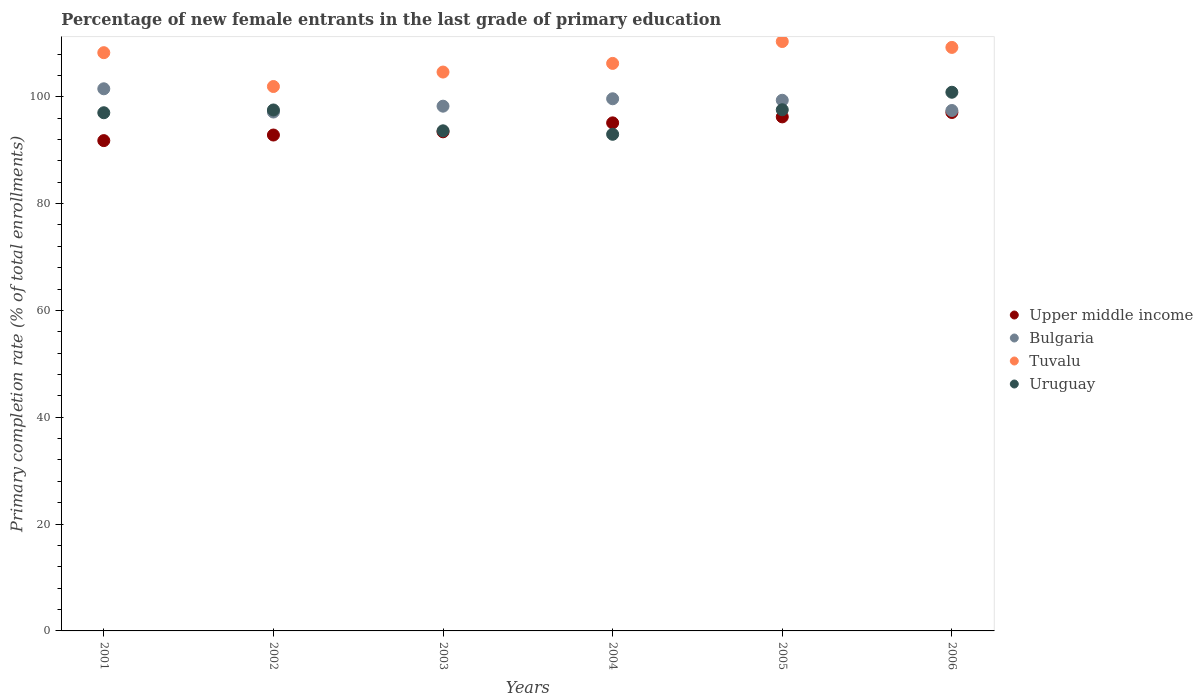How many different coloured dotlines are there?
Provide a short and direct response. 4. What is the percentage of new female entrants in Bulgaria in 2006?
Provide a succinct answer. 97.43. Across all years, what is the maximum percentage of new female entrants in Upper middle income?
Offer a terse response. 97.06. Across all years, what is the minimum percentage of new female entrants in Bulgaria?
Offer a terse response. 97.15. In which year was the percentage of new female entrants in Uruguay minimum?
Keep it short and to the point. 2004. What is the total percentage of new female entrants in Bulgaria in the graph?
Ensure brevity in your answer.  593.3. What is the difference between the percentage of new female entrants in Uruguay in 2004 and that in 2006?
Keep it short and to the point. -7.87. What is the difference between the percentage of new female entrants in Tuvalu in 2005 and the percentage of new female entrants in Upper middle income in 2001?
Provide a short and direct response. 18.55. What is the average percentage of new female entrants in Tuvalu per year?
Offer a very short reply. 106.77. In the year 2003, what is the difference between the percentage of new female entrants in Tuvalu and percentage of new female entrants in Uruguay?
Give a very brief answer. 11. What is the ratio of the percentage of new female entrants in Bulgaria in 2001 to that in 2006?
Provide a short and direct response. 1.04. Is the difference between the percentage of new female entrants in Tuvalu in 2002 and 2003 greater than the difference between the percentage of new female entrants in Uruguay in 2002 and 2003?
Make the answer very short. No. What is the difference between the highest and the second highest percentage of new female entrants in Uruguay?
Your answer should be compact. 3.28. What is the difference between the highest and the lowest percentage of new female entrants in Upper middle income?
Provide a short and direct response. 5.26. In how many years, is the percentage of new female entrants in Upper middle income greater than the average percentage of new female entrants in Upper middle income taken over all years?
Make the answer very short. 3. Is it the case that in every year, the sum of the percentage of new female entrants in Tuvalu and percentage of new female entrants in Upper middle income  is greater than the sum of percentage of new female entrants in Bulgaria and percentage of new female entrants in Uruguay?
Make the answer very short. Yes. Does the percentage of new female entrants in Uruguay monotonically increase over the years?
Give a very brief answer. No. Is the percentage of new female entrants in Bulgaria strictly greater than the percentage of new female entrants in Uruguay over the years?
Provide a short and direct response. No. Is the percentage of new female entrants in Tuvalu strictly less than the percentage of new female entrants in Upper middle income over the years?
Your answer should be compact. No. How many dotlines are there?
Keep it short and to the point. 4. How many years are there in the graph?
Give a very brief answer. 6. What is the difference between two consecutive major ticks on the Y-axis?
Your response must be concise. 20. Does the graph contain any zero values?
Your answer should be compact. No. How many legend labels are there?
Provide a short and direct response. 4. What is the title of the graph?
Your response must be concise. Percentage of new female entrants in the last grade of primary education. What is the label or title of the Y-axis?
Give a very brief answer. Primary completion rate (% of total enrollments). What is the Primary completion rate (% of total enrollments) in Upper middle income in 2001?
Your answer should be compact. 91.79. What is the Primary completion rate (% of total enrollments) of Bulgaria in 2001?
Offer a terse response. 101.5. What is the Primary completion rate (% of total enrollments) in Tuvalu in 2001?
Your answer should be very brief. 108.26. What is the Primary completion rate (% of total enrollments) of Uruguay in 2001?
Your response must be concise. 97.01. What is the Primary completion rate (% of total enrollments) of Upper middle income in 2002?
Provide a short and direct response. 92.84. What is the Primary completion rate (% of total enrollments) of Bulgaria in 2002?
Your answer should be very brief. 97.15. What is the Primary completion rate (% of total enrollments) of Tuvalu in 2002?
Your answer should be compact. 101.92. What is the Primary completion rate (% of total enrollments) in Uruguay in 2002?
Provide a succinct answer. 97.53. What is the Primary completion rate (% of total enrollments) in Upper middle income in 2003?
Your answer should be very brief. 93.44. What is the Primary completion rate (% of total enrollments) in Bulgaria in 2003?
Give a very brief answer. 98.24. What is the Primary completion rate (% of total enrollments) in Tuvalu in 2003?
Your answer should be very brief. 104.63. What is the Primary completion rate (% of total enrollments) in Uruguay in 2003?
Ensure brevity in your answer.  93.63. What is the Primary completion rate (% of total enrollments) in Upper middle income in 2004?
Provide a short and direct response. 95.12. What is the Primary completion rate (% of total enrollments) of Bulgaria in 2004?
Give a very brief answer. 99.63. What is the Primary completion rate (% of total enrollments) in Tuvalu in 2004?
Your response must be concise. 106.25. What is the Primary completion rate (% of total enrollments) in Uruguay in 2004?
Offer a very short reply. 92.98. What is the Primary completion rate (% of total enrollments) in Upper middle income in 2005?
Keep it short and to the point. 96.24. What is the Primary completion rate (% of total enrollments) in Bulgaria in 2005?
Give a very brief answer. 99.35. What is the Primary completion rate (% of total enrollments) of Tuvalu in 2005?
Offer a terse response. 110.34. What is the Primary completion rate (% of total enrollments) in Uruguay in 2005?
Your answer should be very brief. 97.57. What is the Primary completion rate (% of total enrollments) of Upper middle income in 2006?
Offer a very short reply. 97.06. What is the Primary completion rate (% of total enrollments) in Bulgaria in 2006?
Keep it short and to the point. 97.43. What is the Primary completion rate (% of total enrollments) in Tuvalu in 2006?
Provide a succinct answer. 109.24. What is the Primary completion rate (% of total enrollments) in Uruguay in 2006?
Keep it short and to the point. 100.85. Across all years, what is the maximum Primary completion rate (% of total enrollments) in Upper middle income?
Give a very brief answer. 97.06. Across all years, what is the maximum Primary completion rate (% of total enrollments) of Bulgaria?
Your response must be concise. 101.5. Across all years, what is the maximum Primary completion rate (% of total enrollments) in Tuvalu?
Make the answer very short. 110.34. Across all years, what is the maximum Primary completion rate (% of total enrollments) of Uruguay?
Make the answer very short. 100.85. Across all years, what is the minimum Primary completion rate (% of total enrollments) in Upper middle income?
Your answer should be compact. 91.79. Across all years, what is the minimum Primary completion rate (% of total enrollments) in Bulgaria?
Your answer should be compact. 97.15. Across all years, what is the minimum Primary completion rate (% of total enrollments) in Tuvalu?
Your answer should be compact. 101.92. Across all years, what is the minimum Primary completion rate (% of total enrollments) of Uruguay?
Offer a very short reply. 92.98. What is the total Primary completion rate (% of total enrollments) of Upper middle income in the graph?
Offer a very short reply. 566.49. What is the total Primary completion rate (% of total enrollments) in Bulgaria in the graph?
Keep it short and to the point. 593.3. What is the total Primary completion rate (% of total enrollments) in Tuvalu in the graph?
Provide a short and direct response. 640.65. What is the total Primary completion rate (% of total enrollments) of Uruguay in the graph?
Offer a terse response. 579.57. What is the difference between the Primary completion rate (% of total enrollments) of Upper middle income in 2001 and that in 2002?
Offer a terse response. -1.05. What is the difference between the Primary completion rate (% of total enrollments) in Bulgaria in 2001 and that in 2002?
Make the answer very short. 4.35. What is the difference between the Primary completion rate (% of total enrollments) of Tuvalu in 2001 and that in 2002?
Provide a succinct answer. 6.33. What is the difference between the Primary completion rate (% of total enrollments) in Uruguay in 2001 and that in 2002?
Your answer should be very brief. -0.52. What is the difference between the Primary completion rate (% of total enrollments) of Upper middle income in 2001 and that in 2003?
Your answer should be compact. -1.65. What is the difference between the Primary completion rate (% of total enrollments) in Bulgaria in 2001 and that in 2003?
Provide a succinct answer. 3.26. What is the difference between the Primary completion rate (% of total enrollments) of Tuvalu in 2001 and that in 2003?
Offer a terse response. 3.63. What is the difference between the Primary completion rate (% of total enrollments) in Uruguay in 2001 and that in 2003?
Your answer should be very brief. 3.38. What is the difference between the Primary completion rate (% of total enrollments) of Upper middle income in 2001 and that in 2004?
Ensure brevity in your answer.  -3.32. What is the difference between the Primary completion rate (% of total enrollments) of Bulgaria in 2001 and that in 2004?
Your answer should be compact. 1.87. What is the difference between the Primary completion rate (% of total enrollments) of Tuvalu in 2001 and that in 2004?
Your response must be concise. 2.01. What is the difference between the Primary completion rate (% of total enrollments) in Uruguay in 2001 and that in 2004?
Your answer should be compact. 4.03. What is the difference between the Primary completion rate (% of total enrollments) in Upper middle income in 2001 and that in 2005?
Offer a terse response. -4.44. What is the difference between the Primary completion rate (% of total enrollments) in Bulgaria in 2001 and that in 2005?
Provide a short and direct response. 2.15. What is the difference between the Primary completion rate (% of total enrollments) in Tuvalu in 2001 and that in 2005?
Your answer should be compact. -2.09. What is the difference between the Primary completion rate (% of total enrollments) of Uruguay in 2001 and that in 2005?
Offer a terse response. -0.56. What is the difference between the Primary completion rate (% of total enrollments) in Upper middle income in 2001 and that in 2006?
Ensure brevity in your answer.  -5.26. What is the difference between the Primary completion rate (% of total enrollments) in Bulgaria in 2001 and that in 2006?
Your answer should be very brief. 4.07. What is the difference between the Primary completion rate (% of total enrollments) of Tuvalu in 2001 and that in 2006?
Your answer should be very brief. -0.99. What is the difference between the Primary completion rate (% of total enrollments) of Uruguay in 2001 and that in 2006?
Your answer should be compact. -3.84. What is the difference between the Primary completion rate (% of total enrollments) of Upper middle income in 2002 and that in 2003?
Give a very brief answer. -0.6. What is the difference between the Primary completion rate (% of total enrollments) of Bulgaria in 2002 and that in 2003?
Offer a very short reply. -1.1. What is the difference between the Primary completion rate (% of total enrollments) of Tuvalu in 2002 and that in 2003?
Provide a short and direct response. -2.71. What is the difference between the Primary completion rate (% of total enrollments) of Uruguay in 2002 and that in 2003?
Your response must be concise. 3.9. What is the difference between the Primary completion rate (% of total enrollments) of Upper middle income in 2002 and that in 2004?
Provide a short and direct response. -2.28. What is the difference between the Primary completion rate (% of total enrollments) in Bulgaria in 2002 and that in 2004?
Provide a succinct answer. -2.48. What is the difference between the Primary completion rate (% of total enrollments) of Tuvalu in 2002 and that in 2004?
Ensure brevity in your answer.  -4.33. What is the difference between the Primary completion rate (% of total enrollments) of Uruguay in 2002 and that in 2004?
Make the answer very short. 4.55. What is the difference between the Primary completion rate (% of total enrollments) of Upper middle income in 2002 and that in 2005?
Keep it short and to the point. -3.4. What is the difference between the Primary completion rate (% of total enrollments) in Bulgaria in 2002 and that in 2005?
Provide a short and direct response. -2.2. What is the difference between the Primary completion rate (% of total enrollments) of Tuvalu in 2002 and that in 2005?
Ensure brevity in your answer.  -8.42. What is the difference between the Primary completion rate (% of total enrollments) in Uruguay in 2002 and that in 2005?
Keep it short and to the point. -0.04. What is the difference between the Primary completion rate (% of total enrollments) in Upper middle income in 2002 and that in 2006?
Make the answer very short. -4.22. What is the difference between the Primary completion rate (% of total enrollments) of Bulgaria in 2002 and that in 2006?
Keep it short and to the point. -0.29. What is the difference between the Primary completion rate (% of total enrollments) in Tuvalu in 2002 and that in 2006?
Your answer should be compact. -7.32. What is the difference between the Primary completion rate (% of total enrollments) in Uruguay in 2002 and that in 2006?
Your response must be concise. -3.32. What is the difference between the Primary completion rate (% of total enrollments) of Upper middle income in 2003 and that in 2004?
Your response must be concise. -1.68. What is the difference between the Primary completion rate (% of total enrollments) of Bulgaria in 2003 and that in 2004?
Make the answer very short. -1.39. What is the difference between the Primary completion rate (% of total enrollments) in Tuvalu in 2003 and that in 2004?
Provide a short and direct response. -1.62. What is the difference between the Primary completion rate (% of total enrollments) in Uruguay in 2003 and that in 2004?
Your response must be concise. 0.65. What is the difference between the Primary completion rate (% of total enrollments) of Upper middle income in 2003 and that in 2005?
Your answer should be compact. -2.8. What is the difference between the Primary completion rate (% of total enrollments) in Bulgaria in 2003 and that in 2005?
Your answer should be very brief. -1.1. What is the difference between the Primary completion rate (% of total enrollments) of Tuvalu in 2003 and that in 2005?
Make the answer very short. -5.72. What is the difference between the Primary completion rate (% of total enrollments) in Uruguay in 2003 and that in 2005?
Your answer should be compact. -3.94. What is the difference between the Primary completion rate (% of total enrollments) of Upper middle income in 2003 and that in 2006?
Make the answer very short. -3.62. What is the difference between the Primary completion rate (% of total enrollments) of Bulgaria in 2003 and that in 2006?
Your answer should be compact. 0.81. What is the difference between the Primary completion rate (% of total enrollments) in Tuvalu in 2003 and that in 2006?
Offer a terse response. -4.61. What is the difference between the Primary completion rate (% of total enrollments) in Uruguay in 2003 and that in 2006?
Make the answer very short. -7.22. What is the difference between the Primary completion rate (% of total enrollments) in Upper middle income in 2004 and that in 2005?
Keep it short and to the point. -1.12. What is the difference between the Primary completion rate (% of total enrollments) of Bulgaria in 2004 and that in 2005?
Keep it short and to the point. 0.28. What is the difference between the Primary completion rate (% of total enrollments) in Tuvalu in 2004 and that in 2005?
Provide a succinct answer. -4.09. What is the difference between the Primary completion rate (% of total enrollments) of Uruguay in 2004 and that in 2005?
Your response must be concise. -4.59. What is the difference between the Primary completion rate (% of total enrollments) in Upper middle income in 2004 and that in 2006?
Give a very brief answer. -1.94. What is the difference between the Primary completion rate (% of total enrollments) of Bulgaria in 2004 and that in 2006?
Make the answer very short. 2.2. What is the difference between the Primary completion rate (% of total enrollments) in Tuvalu in 2004 and that in 2006?
Keep it short and to the point. -2.99. What is the difference between the Primary completion rate (% of total enrollments) in Uruguay in 2004 and that in 2006?
Provide a succinct answer. -7.87. What is the difference between the Primary completion rate (% of total enrollments) of Upper middle income in 2005 and that in 2006?
Provide a succinct answer. -0.82. What is the difference between the Primary completion rate (% of total enrollments) of Bulgaria in 2005 and that in 2006?
Offer a very short reply. 1.91. What is the difference between the Primary completion rate (% of total enrollments) of Tuvalu in 2005 and that in 2006?
Offer a very short reply. 1.1. What is the difference between the Primary completion rate (% of total enrollments) in Uruguay in 2005 and that in 2006?
Your response must be concise. -3.28. What is the difference between the Primary completion rate (% of total enrollments) in Upper middle income in 2001 and the Primary completion rate (% of total enrollments) in Bulgaria in 2002?
Provide a succinct answer. -5.35. What is the difference between the Primary completion rate (% of total enrollments) in Upper middle income in 2001 and the Primary completion rate (% of total enrollments) in Tuvalu in 2002?
Offer a terse response. -10.13. What is the difference between the Primary completion rate (% of total enrollments) in Upper middle income in 2001 and the Primary completion rate (% of total enrollments) in Uruguay in 2002?
Make the answer very short. -5.74. What is the difference between the Primary completion rate (% of total enrollments) in Bulgaria in 2001 and the Primary completion rate (% of total enrollments) in Tuvalu in 2002?
Your answer should be compact. -0.43. What is the difference between the Primary completion rate (% of total enrollments) in Bulgaria in 2001 and the Primary completion rate (% of total enrollments) in Uruguay in 2002?
Your response must be concise. 3.97. What is the difference between the Primary completion rate (% of total enrollments) in Tuvalu in 2001 and the Primary completion rate (% of total enrollments) in Uruguay in 2002?
Make the answer very short. 10.73. What is the difference between the Primary completion rate (% of total enrollments) of Upper middle income in 2001 and the Primary completion rate (% of total enrollments) of Bulgaria in 2003?
Offer a very short reply. -6.45. What is the difference between the Primary completion rate (% of total enrollments) of Upper middle income in 2001 and the Primary completion rate (% of total enrollments) of Tuvalu in 2003?
Your answer should be compact. -12.84. What is the difference between the Primary completion rate (% of total enrollments) in Upper middle income in 2001 and the Primary completion rate (% of total enrollments) in Uruguay in 2003?
Ensure brevity in your answer.  -1.83. What is the difference between the Primary completion rate (% of total enrollments) of Bulgaria in 2001 and the Primary completion rate (% of total enrollments) of Tuvalu in 2003?
Your answer should be very brief. -3.13. What is the difference between the Primary completion rate (% of total enrollments) in Bulgaria in 2001 and the Primary completion rate (% of total enrollments) in Uruguay in 2003?
Provide a short and direct response. 7.87. What is the difference between the Primary completion rate (% of total enrollments) in Tuvalu in 2001 and the Primary completion rate (% of total enrollments) in Uruguay in 2003?
Your response must be concise. 14.63. What is the difference between the Primary completion rate (% of total enrollments) of Upper middle income in 2001 and the Primary completion rate (% of total enrollments) of Bulgaria in 2004?
Offer a terse response. -7.83. What is the difference between the Primary completion rate (% of total enrollments) in Upper middle income in 2001 and the Primary completion rate (% of total enrollments) in Tuvalu in 2004?
Ensure brevity in your answer.  -14.46. What is the difference between the Primary completion rate (% of total enrollments) of Upper middle income in 2001 and the Primary completion rate (% of total enrollments) of Uruguay in 2004?
Your answer should be compact. -1.18. What is the difference between the Primary completion rate (% of total enrollments) of Bulgaria in 2001 and the Primary completion rate (% of total enrollments) of Tuvalu in 2004?
Make the answer very short. -4.75. What is the difference between the Primary completion rate (% of total enrollments) in Bulgaria in 2001 and the Primary completion rate (% of total enrollments) in Uruguay in 2004?
Your response must be concise. 8.52. What is the difference between the Primary completion rate (% of total enrollments) in Tuvalu in 2001 and the Primary completion rate (% of total enrollments) in Uruguay in 2004?
Ensure brevity in your answer.  15.28. What is the difference between the Primary completion rate (% of total enrollments) in Upper middle income in 2001 and the Primary completion rate (% of total enrollments) in Bulgaria in 2005?
Ensure brevity in your answer.  -7.55. What is the difference between the Primary completion rate (% of total enrollments) in Upper middle income in 2001 and the Primary completion rate (% of total enrollments) in Tuvalu in 2005?
Keep it short and to the point. -18.55. What is the difference between the Primary completion rate (% of total enrollments) in Upper middle income in 2001 and the Primary completion rate (% of total enrollments) in Uruguay in 2005?
Provide a short and direct response. -5.78. What is the difference between the Primary completion rate (% of total enrollments) of Bulgaria in 2001 and the Primary completion rate (% of total enrollments) of Tuvalu in 2005?
Offer a very short reply. -8.85. What is the difference between the Primary completion rate (% of total enrollments) in Bulgaria in 2001 and the Primary completion rate (% of total enrollments) in Uruguay in 2005?
Give a very brief answer. 3.93. What is the difference between the Primary completion rate (% of total enrollments) of Tuvalu in 2001 and the Primary completion rate (% of total enrollments) of Uruguay in 2005?
Offer a terse response. 10.68. What is the difference between the Primary completion rate (% of total enrollments) in Upper middle income in 2001 and the Primary completion rate (% of total enrollments) in Bulgaria in 2006?
Your answer should be compact. -5.64. What is the difference between the Primary completion rate (% of total enrollments) of Upper middle income in 2001 and the Primary completion rate (% of total enrollments) of Tuvalu in 2006?
Your response must be concise. -17.45. What is the difference between the Primary completion rate (% of total enrollments) of Upper middle income in 2001 and the Primary completion rate (% of total enrollments) of Uruguay in 2006?
Offer a terse response. -9.05. What is the difference between the Primary completion rate (% of total enrollments) of Bulgaria in 2001 and the Primary completion rate (% of total enrollments) of Tuvalu in 2006?
Ensure brevity in your answer.  -7.75. What is the difference between the Primary completion rate (% of total enrollments) in Bulgaria in 2001 and the Primary completion rate (% of total enrollments) in Uruguay in 2006?
Make the answer very short. 0.65. What is the difference between the Primary completion rate (% of total enrollments) in Tuvalu in 2001 and the Primary completion rate (% of total enrollments) in Uruguay in 2006?
Ensure brevity in your answer.  7.41. What is the difference between the Primary completion rate (% of total enrollments) of Upper middle income in 2002 and the Primary completion rate (% of total enrollments) of Bulgaria in 2003?
Keep it short and to the point. -5.4. What is the difference between the Primary completion rate (% of total enrollments) in Upper middle income in 2002 and the Primary completion rate (% of total enrollments) in Tuvalu in 2003?
Make the answer very short. -11.79. What is the difference between the Primary completion rate (% of total enrollments) of Upper middle income in 2002 and the Primary completion rate (% of total enrollments) of Uruguay in 2003?
Your answer should be compact. -0.79. What is the difference between the Primary completion rate (% of total enrollments) of Bulgaria in 2002 and the Primary completion rate (% of total enrollments) of Tuvalu in 2003?
Make the answer very short. -7.48. What is the difference between the Primary completion rate (% of total enrollments) of Bulgaria in 2002 and the Primary completion rate (% of total enrollments) of Uruguay in 2003?
Give a very brief answer. 3.52. What is the difference between the Primary completion rate (% of total enrollments) in Tuvalu in 2002 and the Primary completion rate (% of total enrollments) in Uruguay in 2003?
Make the answer very short. 8.29. What is the difference between the Primary completion rate (% of total enrollments) in Upper middle income in 2002 and the Primary completion rate (% of total enrollments) in Bulgaria in 2004?
Offer a very short reply. -6.79. What is the difference between the Primary completion rate (% of total enrollments) of Upper middle income in 2002 and the Primary completion rate (% of total enrollments) of Tuvalu in 2004?
Keep it short and to the point. -13.41. What is the difference between the Primary completion rate (% of total enrollments) of Upper middle income in 2002 and the Primary completion rate (% of total enrollments) of Uruguay in 2004?
Your answer should be compact. -0.14. What is the difference between the Primary completion rate (% of total enrollments) in Bulgaria in 2002 and the Primary completion rate (% of total enrollments) in Tuvalu in 2004?
Offer a terse response. -9.1. What is the difference between the Primary completion rate (% of total enrollments) in Bulgaria in 2002 and the Primary completion rate (% of total enrollments) in Uruguay in 2004?
Your answer should be compact. 4.17. What is the difference between the Primary completion rate (% of total enrollments) of Tuvalu in 2002 and the Primary completion rate (% of total enrollments) of Uruguay in 2004?
Provide a short and direct response. 8.94. What is the difference between the Primary completion rate (% of total enrollments) of Upper middle income in 2002 and the Primary completion rate (% of total enrollments) of Bulgaria in 2005?
Ensure brevity in your answer.  -6.51. What is the difference between the Primary completion rate (% of total enrollments) of Upper middle income in 2002 and the Primary completion rate (% of total enrollments) of Tuvalu in 2005?
Your answer should be compact. -17.5. What is the difference between the Primary completion rate (% of total enrollments) of Upper middle income in 2002 and the Primary completion rate (% of total enrollments) of Uruguay in 2005?
Offer a very short reply. -4.73. What is the difference between the Primary completion rate (% of total enrollments) of Bulgaria in 2002 and the Primary completion rate (% of total enrollments) of Tuvalu in 2005?
Offer a very short reply. -13.2. What is the difference between the Primary completion rate (% of total enrollments) of Bulgaria in 2002 and the Primary completion rate (% of total enrollments) of Uruguay in 2005?
Keep it short and to the point. -0.43. What is the difference between the Primary completion rate (% of total enrollments) of Tuvalu in 2002 and the Primary completion rate (% of total enrollments) of Uruguay in 2005?
Offer a terse response. 4.35. What is the difference between the Primary completion rate (% of total enrollments) of Upper middle income in 2002 and the Primary completion rate (% of total enrollments) of Bulgaria in 2006?
Keep it short and to the point. -4.59. What is the difference between the Primary completion rate (% of total enrollments) of Upper middle income in 2002 and the Primary completion rate (% of total enrollments) of Tuvalu in 2006?
Offer a very short reply. -16.4. What is the difference between the Primary completion rate (% of total enrollments) in Upper middle income in 2002 and the Primary completion rate (% of total enrollments) in Uruguay in 2006?
Your response must be concise. -8.01. What is the difference between the Primary completion rate (% of total enrollments) of Bulgaria in 2002 and the Primary completion rate (% of total enrollments) of Tuvalu in 2006?
Provide a short and direct response. -12.1. What is the difference between the Primary completion rate (% of total enrollments) in Bulgaria in 2002 and the Primary completion rate (% of total enrollments) in Uruguay in 2006?
Keep it short and to the point. -3.7. What is the difference between the Primary completion rate (% of total enrollments) in Tuvalu in 2002 and the Primary completion rate (% of total enrollments) in Uruguay in 2006?
Make the answer very short. 1.07. What is the difference between the Primary completion rate (% of total enrollments) of Upper middle income in 2003 and the Primary completion rate (% of total enrollments) of Bulgaria in 2004?
Ensure brevity in your answer.  -6.19. What is the difference between the Primary completion rate (% of total enrollments) in Upper middle income in 2003 and the Primary completion rate (% of total enrollments) in Tuvalu in 2004?
Give a very brief answer. -12.81. What is the difference between the Primary completion rate (% of total enrollments) in Upper middle income in 2003 and the Primary completion rate (% of total enrollments) in Uruguay in 2004?
Offer a terse response. 0.46. What is the difference between the Primary completion rate (% of total enrollments) of Bulgaria in 2003 and the Primary completion rate (% of total enrollments) of Tuvalu in 2004?
Your answer should be very brief. -8.01. What is the difference between the Primary completion rate (% of total enrollments) of Bulgaria in 2003 and the Primary completion rate (% of total enrollments) of Uruguay in 2004?
Offer a terse response. 5.26. What is the difference between the Primary completion rate (% of total enrollments) of Tuvalu in 2003 and the Primary completion rate (% of total enrollments) of Uruguay in 2004?
Offer a terse response. 11.65. What is the difference between the Primary completion rate (% of total enrollments) in Upper middle income in 2003 and the Primary completion rate (% of total enrollments) in Bulgaria in 2005?
Your response must be concise. -5.91. What is the difference between the Primary completion rate (% of total enrollments) of Upper middle income in 2003 and the Primary completion rate (% of total enrollments) of Tuvalu in 2005?
Make the answer very short. -16.9. What is the difference between the Primary completion rate (% of total enrollments) of Upper middle income in 2003 and the Primary completion rate (% of total enrollments) of Uruguay in 2005?
Provide a short and direct response. -4.13. What is the difference between the Primary completion rate (% of total enrollments) in Bulgaria in 2003 and the Primary completion rate (% of total enrollments) in Tuvalu in 2005?
Ensure brevity in your answer.  -12.1. What is the difference between the Primary completion rate (% of total enrollments) in Bulgaria in 2003 and the Primary completion rate (% of total enrollments) in Uruguay in 2005?
Your answer should be very brief. 0.67. What is the difference between the Primary completion rate (% of total enrollments) in Tuvalu in 2003 and the Primary completion rate (% of total enrollments) in Uruguay in 2005?
Provide a succinct answer. 7.06. What is the difference between the Primary completion rate (% of total enrollments) in Upper middle income in 2003 and the Primary completion rate (% of total enrollments) in Bulgaria in 2006?
Offer a very short reply. -3.99. What is the difference between the Primary completion rate (% of total enrollments) of Upper middle income in 2003 and the Primary completion rate (% of total enrollments) of Tuvalu in 2006?
Offer a terse response. -15.8. What is the difference between the Primary completion rate (% of total enrollments) in Upper middle income in 2003 and the Primary completion rate (% of total enrollments) in Uruguay in 2006?
Ensure brevity in your answer.  -7.41. What is the difference between the Primary completion rate (% of total enrollments) of Bulgaria in 2003 and the Primary completion rate (% of total enrollments) of Tuvalu in 2006?
Make the answer very short. -11. What is the difference between the Primary completion rate (% of total enrollments) in Bulgaria in 2003 and the Primary completion rate (% of total enrollments) in Uruguay in 2006?
Ensure brevity in your answer.  -2.61. What is the difference between the Primary completion rate (% of total enrollments) of Tuvalu in 2003 and the Primary completion rate (% of total enrollments) of Uruguay in 2006?
Ensure brevity in your answer.  3.78. What is the difference between the Primary completion rate (% of total enrollments) of Upper middle income in 2004 and the Primary completion rate (% of total enrollments) of Bulgaria in 2005?
Provide a succinct answer. -4.23. What is the difference between the Primary completion rate (% of total enrollments) in Upper middle income in 2004 and the Primary completion rate (% of total enrollments) in Tuvalu in 2005?
Your response must be concise. -15.23. What is the difference between the Primary completion rate (% of total enrollments) of Upper middle income in 2004 and the Primary completion rate (% of total enrollments) of Uruguay in 2005?
Provide a succinct answer. -2.45. What is the difference between the Primary completion rate (% of total enrollments) in Bulgaria in 2004 and the Primary completion rate (% of total enrollments) in Tuvalu in 2005?
Provide a succinct answer. -10.72. What is the difference between the Primary completion rate (% of total enrollments) of Bulgaria in 2004 and the Primary completion rate (% of total enrollments) of Uruguay in 2005?
Make the answer very short. 2.06. What is the difference between the Primary completion rate (% of total enrollments) in Tuvalu in 2004 and the Primary completion rate (% of total enrollments) in Uruguay in 2005?
Your answer should be compact. 8.68. What is the difference between the Primary completion rate (% of total enrollments) of Upper middle income in 2004 and the Primary completion rate (% of total enrollments) of Bulgaria in 2006?
Ensure brevity in your answer.  -2.31. What is the difference between the Primary completion rate (% of total enrollments) in Upper middle income in 2004 and the Primary completion rate (% of total enrollments) in Tuvalu in 2006?
Keep it short and to the point. -14.13. What is the difference between the Primary completion rate (% of total enrollments) in Upper middle income in 2004 and the Primary completion rate (% of total enrollments) in Uruguay in 2006?
Offer a very short reply. -5.73. What is the difference between the Primary completion rate (% of total enrollments) in Bulgaria in 2004 and the Primary completion rate (% of total enrollments) in Tuvalu in 2006?
Your response must be concise. -9.61. What is the difference between the Primary completion rate (% of total enrollments) in Bulgaria in 2004 and the Primary completion rate (% of total enrollments) in Uruguay in 2006?
Your answer should be very brief. -1.22. What is the difference between the Primary completion rate (% of total enrollments) of Tuvalu in 2004 and the Primary completion rate (% of total enrollments) of Uruguay in 2006?
Offer a very short reply. 5.4. What is the difference between the Primary completion rate (% of total enrollments) of Upper middle income in 2005 and the Primary completion rate (% of total enrollments) of Bulgaria in 2006?
Keep it short and to the point. -1.2. What is the difference between the Primary completion rate (% of total enrollments) in Upper middle income in 2005 and the Primary completion rate (% of total enrollments) in Tuvalu in 2006?
Keep it short and to the point. -13.01. What is the difference between the Primary completion rate (% of total enrollments) of Upper middle income in 2005 and the Primary completion rate (% of total enrollments) of Uruguay in 2006?
Give a very brief answer. -4.61. What is the difference between the Primary completion rate (% of total enrollments) in Bulgaria in 2005 and the Primary completion rate (% of total enrollments) in Tuvalu in 2006?
Provide a succinct answer. -9.9. What is the difference between the Primary completion rate (% of total enrollments) in Bulgaria in 2005 and the Primary completion rate (% of total enrollments) in Uruguay in 2006?
Your answer should be compact. -1.5. What is the difference between the Primary completion rate (% of total enrollments) in Tuvalu in 2005 and the Primary completion rate (% of total enrollments) in Uruguay in 2006?
Make the answer very short. 9.5. What is the average Primary completion rate (% of total enrollments) in Upper middle income per year?
Your response must be concise. 94.41. What is the average Primary completion rate (% of total enrollments) in Bulgaria per year?
Keep it short and to the point. 98.88. What is the average Primary completion rate (% of total enrollments) in Tuvalu per year?
Your answer should be compact. 106.77. What is the average Primary completion rate (% of total enrollments) in Uruguay per year?
Make the answer very short. 96.6. In the year 2001, what is the difference between the Primary completion rate (% of total enrollments) of Upper middle income and Primary completion rate (% of total enrollments) of Bulgaria?
Ensure brevity in your answer.  -9.7. In the year 2001, what is the difference between the Primary completion rate (% of total enrollments) in Upper middle income and Primary completion rate (% of total enrollments) in Tuvalu?
Make the answer very short. -16.46. In the year 2001, what is the difference between the Primary completion rate (% of total enrollments) of Upper middle income and Primary completion rate (% of total enrollments) of Uruguay?
Offer a very short reply. -5.22. In the year 2001, what is the difference between the Primary completion rate (% of total enrollments) of Bulgaria and Primary completion rate (% of total enrollments) of Tuvalu?
Your response must be concise. -6.76. In the year 2001, what is the difference between the Primary completion rate (% of total enrollments) of Bulgaria and Primary completion rate (% of total enrollments) of Uruguay?
Your answer should be compact. 4.49. In the year 2001, what is the difference between the Primary completion rate (% of total enrollments) of Tuvalu and Primary completion rate (% of total enrollments) of Uruguay?
Your answer should be compact. 11.24. In the year 2002, what is the difference between the Primary completion rate (% of total enrollments) of Upper middle income and Primary completion rate (% of total enrollments) of Bulgaria?
Make the answer very short. -4.31. In the year 2002, what is the difference between the Primary completion rate (% of total enrollments) in Upper middle income and Primary completion rate (% of total enrollments) in Tuvalu?
Your response must be concise. -9.08. In the year 2002, what is the difference between the Primary completion rate (% of total enrollments) in Upper middle income and Primary completion rate (% of total enrollments) in Uruguay?
Offer a very short reply. -4.69. In the year 2002, what is the difference between the Primary completion rate (% of total enrollments) in Bulgaria and Primary completion rate (% of total enrollments) in Tuvalu?
Your response must be concise. -4.78. In the year 2002, what is the difference between the Primary completion rate (% of total enrollments) in Bulgaria and Primary completion rate (% of total enrollments) in Uruguay?
Offer a terse response. -0.38. In the year 2002, what is the difference between the Primary completion rate (% of total enrollments) in Tuvalu and Primary completion rate (% of total enrollments) in Uruguay?
Keep it short and to the point. 4.39. In the year 2003, what is the difference between the Primary completion rate (% of total enrollments) in Upper middle income and Primary completion rate (% of total enrollments) in Bulgaria?
Make the answer very short. -4.8. In the year 2003, what is the difference between the Primary completion rate (% of total enrollments) in Upper middle income and Primary completion rate (% of total enrollments) in Tuvalu?
Offer a terse response. -11.19. In the year 2003, what is the difference between the Primary completion rate (% of total enrollments) in Upper middle income and Primary completion rate (% of total enrollments) in Uruguay?
Your response must be concise. -0.19. In the year 2003, what is the difference between the Primary completion rate (% of total enrollments) in Bulgaria and Primary completion rate (% of total enrollments) in Tuvalu?
Provide a short and direct response. -6.39. In the year 2003, what is the difference between the Primary completion rate (% of total enrollments) in Bulgaria and Primary completion rate (% of total enrollments) in Uruguay?
Your response must be concise. 4.61. In the year 2003, what is the difference between the Primary completion rate (% of total enrollments) of Tuvalu and Primary completion rate (% of total enrollments) of Uruguay?
Keep it short and to the point. 11. In the year 2004, what is the difference between the Primary completion rate (% of total enrollments) of Upper middle income and Primary completion rate (% of total enrollments) of Bulgaria?
Offer a very short reply. -4.51. In the year 2004, what is the difference between the Primary completion rate (% of total enrollments) in Upper middle income and Primary completion rate (% of total enrollments) in Tuvalu?
Your answer should be compact. -11.13. In the year 2004, what is the difference between the Primary completion rate (% of total enrollments) of Upper middle income and Primary completion rate (% of total enrollments) of Uruguay?
Offer a terse response. 2.14. In the year 2004, what is the difference between the Primary completion rate (% of total enrollments) of Bulgaria and Primary completion rate (% of total enrollments) of Tuvalu?
Give a very brief answer. -6.62. In the year 2004, what is the difference between the Primary completion rate (% of total enrollments) of Bulgaria and Primary completion rate (% of total enrollments) of Uruguay?
Keep it short and to the point. 6.65. In the year 2004, what is the difference between the Primary completion rate (% of total enrollments) in Tuvalu and Primary completion rate (% of total enrollments) in Uruguay?
Your answer should be compact. 13.27. In the year 2005, what is the difference between the Primary completion rate (% of total enrollments) of Upper middle income and Primary completion rate (% of total enrollments) of Bulgaria?
Your response must be concise. -3.11. In the year 2005, what is the difference between the Primary completion rate (% of total enrollments) in Upper middle income and Primary completion rate (% of total enrollments) in Tuvalu?
Give a very brief answer. -14.11. In the year 2005, what is the difference between the Primary completion rate (% of total enrollments) of Upper middle income and Primary completion rate (% of total enrollments) of Uruguay?
Your answer should be very brief. -1.34. In the year 2005, what is the difference between the Primary completion rate (% of total enrollments) of Bulgaria and Primary completion rate (% of total enrollments) of Tuvalu?
Your answer should be compact. -11. In the year 2005, what is the difference between the Primary completion rate (% of total enrollments) of Bulgaria and Primary completion rate (% of total enrollments) of Uruguay?
Ensure brevity in your answer.  1.77. In the year 2005, what is the difference between the Primary completion rate (% of total enrollments) of Tuvalu and Primary completion rate (% of total enrollments) of Uruguay?
Your response must be concise. 12.77. In the year 2006, what is the difference between the Primary completion rate (% of total enrollments) in Upper middle income and Primary completion rate (% of total enrollments) in Bulgaria?
Provide a succinct answer. -0.37. In the year 2006, what is the difference between the Primary completion rate (% of total enrollments) in Upper middle income and Primary completion rate (% of total enrollments) in Tuvalu?
Offer a very short reply. -12.19. In the year 2006, what is the difference between the Primary completion rate (% of total enrollments) in Upper middle income and Primary completion rate (% of total enrollments) in Uruguay?
Provide a succinct answer. -3.79. In the year 2006, what is the difference between the Primary completion rate (% of total enrollments) of Bulgaria and Primary completion rate (% of total enrollments) of Tuvalu?
Your answer should be very brief. -11.81. In the year 2006, what is the difference between the Primary completion rate (% of total enrollments) in Bulgaria and Primary completion rate (% of total enrollments) in Uruguay?
Keep it short and to the point. -3.42. In the year 2006, what is the difference between the Primary completion rate (% of total enrollments) of Tuvalu and Primary completion rate (% of total enrollments) of Uruguay?
Make the answer very short. 8.39. What is the ratio of the Primary completion rate (% of total enrollments) of Upper middle income in 2001 to that in 2002?
Offer a terse response. 0.99. What is the ratio of the Primary completion rate (% of total enrollments) in Bulgaria in 2001 to that in 2002?
Provide a succinct answer. 1.04. What is the ratio of the Primary completion rate (% of total enrollments) in Tuvalu in 2001 to that in 2002?
Offer a terse response. 1.06. What is the ratio of the Primary completion rate (% of total enrollments) in Uruguay in 2001 to that in 2002?
Offer a terse response. 0.99. What is the ratio of the Primary completion rate (% of total enrollments) of Upper middle income in 2001 to that in 2003?
Give a very brief answer. 0.98. What is the ratio of the Primary completion rate (% of total enrollments) in Bulgaria in 2001 to that in 2003?
Your response must be concise. 1.03. What is the ratio of the Primary completion rate (% of total enrollments) in Tuvalu in 2001 to that in 2003?
Keep it short and to the point. 1.03. What is the ratio of the Primary completion rate (% of total enrollments) of Uruguay in 2001 to that in 2003?
Make the answer very short. 1.04. What is the ratio of the Primary completion rate (% of total enrollments) in Upper middle income in 2001 to that in 2004?
Make the answer very short. 0.97. What is the ratio of the Primary completion rate (% of total enrollments) in Bulgaria in 2001 to that in 2004?
Your answer should be very brief. 1.02. What is the ratio of the Primary completion rate (% of total enrollments) of Tuvalu in 2001 to that in 2004?
Ensure brevity in your answer.  1.02. What is the ratio of the Primary completion rate (% of total enrollments) of Uruguay in 2001 to that in 2004?
Your answer should be compact. 1.04. What is the ratio of the Primary completion rate (% of total enrollments) of Upper middle income in 2001 to that in 2005?
Offer a very short reply. 0.95. What is the ratio of the Primary completion rate (% of total enrollments) of Bulgaria in 2001 to that in 2005?
Provide a succinct answer. 1.02. What is the ratio of the Primary completion rate (% of total enrollments) of Tuvalu in 2001 to that in 2005?
Make the answer very short. 0.98. What is the ratio of the Primary completion rate (% of total enrollments) of Uruguay in 2001 to that in 2005?
Offer a terse response. 0.99. What is the ratio of the Primary completion rate (% of total enrollments) in Upper middle income in 2001 to that in 2006?
Offer a very short reply. 0.95. What is the ratio of the Primary completion rate (% of total enrollments) of Bulgaria in 2001 to that in 2006?
Offer a very short reply. 1.04. What is the ratio of the Primary completion rate (% of total enrollments) in Tuvalu in 2001 to that in 2006?
Give a very brief answer. 0.99. What is the ratio of the Primary completion rate (% of total enrollments) of Upper middle income in 2002 to that in 2003?
Ensure brevity in your answer.  0.99. What is the ratio of the Primary completion rate (% of total enrollments) of Tuvalu in 2002 to that in 2003?
Provide a short and direct response. 0.97. What is the ratio of the Primary completion rate (% of total enrollments) in Uruguay in 2002 to that in 2003?
Keep it short and to the point. 1.04. What is the ratio of the Primary completion rate (% of total enrollments) of Bulgaria in 2002 to that in 2004?
Provide a short and direct response. 0.98. What is the ratio of the Primary completion rate (% of total enrollments) of Tuvalu in 2002 to that in 2004?
Your response must be concise. 0.96. What is the ratio of the Primary completion rate (% of total enrollments) of Uruguay in 2002 to that in 2004?
Make the answer very short. 1.05. What is the ratio of the Primary completion rate (% of total enrollments) of Upper middle income in 2002 to that in 2005?
Your response must be concise. 0.96. What is the ratio of the Primary completion rate (% of total enrollments) of Bulgaria in 2002 to that in 2005?
Make the answer very short. 0.98. What is the ratio of the Primary completion rate (% of total enrollments) of Tuvalu in 2002 to that in 2005?
Give a very brief answer. 0.92. What is the ratio of the Primary completion rate (% of total enrollments) of Uruguay in 2002 to that in 2005?
Your response must be concise. 1. What is the ratio of the Primary completion rate (% of total enrollments) of Upper middle income in 2002 to that in 2006?
Make the answer very short. 0.96. What is the ratio of the Primary completion rate (% of total enrollments) of Bulgaria in 2002 to that in 2006?
Give a very brief answer. 1. What is the ratio of the Primary completion rate (% of total enrollments) in Tuvalu in 2002 to that in 2006?
Offer a very short reply. 0.93. What is the ratio of the Primary completion rate (% of total enrollments) of Uruguay in 2002 to that in 2006?
Provide a succinct answer. 0.97. What is the ratio of the Primary completion rate (% of total enrollments) of Upper middle income in 2003 to that in 2004?
Provide a short and direct response. 0.98. What is the ratio of the Primary completion rate (% of total enrollments) of Bulgaria in 2003 to that in 2004?
Provide a short and direct response. 0.99. What is the ratio of the Primary completion rate (% of total enrollments) of Tuvalu in 2003 to that in 2004?
Provide a short and direct response. 0.98. What is the ratio of the Primary completion rate (% of total enrollments) in Bulgaria in 2003 to that in 2005?
Your answer should be compact. 0.99. What is the ratio of the Primary completion rate (% of total enrollments) in Tuvalu in 2003 to that in 2005?
Provide a succinct answer. 0.95. What is the ratio of the Primary completion rate (% of total enrollments) in Uruguay in 2003 to that in 2005?
Provide a short and direct response. 0.96. What is the ratio of the Primary completion rate (% of total enrollments) of Upper middle income in 2003 to that in 2006?
Provide a succinct answer. 0.96. What is the ratio of the Primary completion rate (% of total enrollments) in Bulgaria in 2003 to that in 2006?
Give a very brief answer. 1.01. What is the ratio of the Primary completion rate (% of total enrollments) in Tuvalu in 2003 to that in 2006?
Provide a succinct answer. 0.96. What is the ratio of the Primary completion rate (% of total enrollments) in Uruguay in 2003 to that in 2006?
Your response must be concise. 0.93. What is the ratio of the Primary completion rate (% of total enrollments) of Upper middle income in 2004 to that in 2005?
Provide a short and direct response. 0.99. What is the ratio of the Primary completion rate (% of total enrollments) of Tuvalu in 2004 to that in 2005?
Make the answer very short. 0.96. What is the ratio of the Primary completion rate (% of total enrollments) in Uruguay in 2004 to that in 2005?
Give a very brief answer. 0.95. What is the ratio of the Primary completion rate (% of total enrollments) in Upper middle income in 2004 to that in 2006?
Your answer should be compact. 0.98. What is the ratio of the Primary completion rate (% of total enrollments) of Bulgaria in 2004 to that in 2006?
Give a very brief answer. 1.02. What is the ratio of the Primary completion rate (% of total enrollments) of Tuvalu in 2004 to that in 2006?
Your answer should be compact. 0.97. What is the ratio of the Primary completion rate (% of total enrollments) in Uruguay in 2004 to that in 2006?
Keep it short and to the point. 0.92. What is the ratio of the Primary completion rate (% of total enrollments) in Bulgaria in 2005 to that in 2006?
Make the answer very short. 1.02. What is the ratio of the Primary completion rate (% of total enrollments) of Uruguay in 2005 to that in 2006?
Your answer should be very brief. 0.97. What is the difference between the highest and the second highest Primary completion rate (% of total enrollments) of Upper middle income?
Offer a terse response. 0.82. What is the difference between the highest and the second highest Primary completion rate (% of total enrollments) in Bulgaria?
Provide a short and direct response. 1.87. What is the difference between the highest and the second highest Primary completion rate (% of total enrollments) in Tuvalu?
Your answer should be very brief. 1.1. What is the difference between the highest and the second highest Primary completion rate (% of total enrollments) in Uruguay?
Your answer should be compact. 3.28. What is the difference between the highest and the lowest Primary completion rate (% of total enrollments) of Upper middle income?
Give a very brief answer. 5.26. What is the difference between the highest and the lowest Primary completion rate (% of total enrollments) in Bulgaria?
Offer a very short reply. 4.35. What is the difference between the highest and the lowest Primary completion rate (% of total enrollments) of Tuvalu?
Give a very brief answer. 8.42. What is the difference between the highest and the lowest Primary completion rate (% of total enrollments) in Uruguay?
Give a very brief answer. 7.87. 